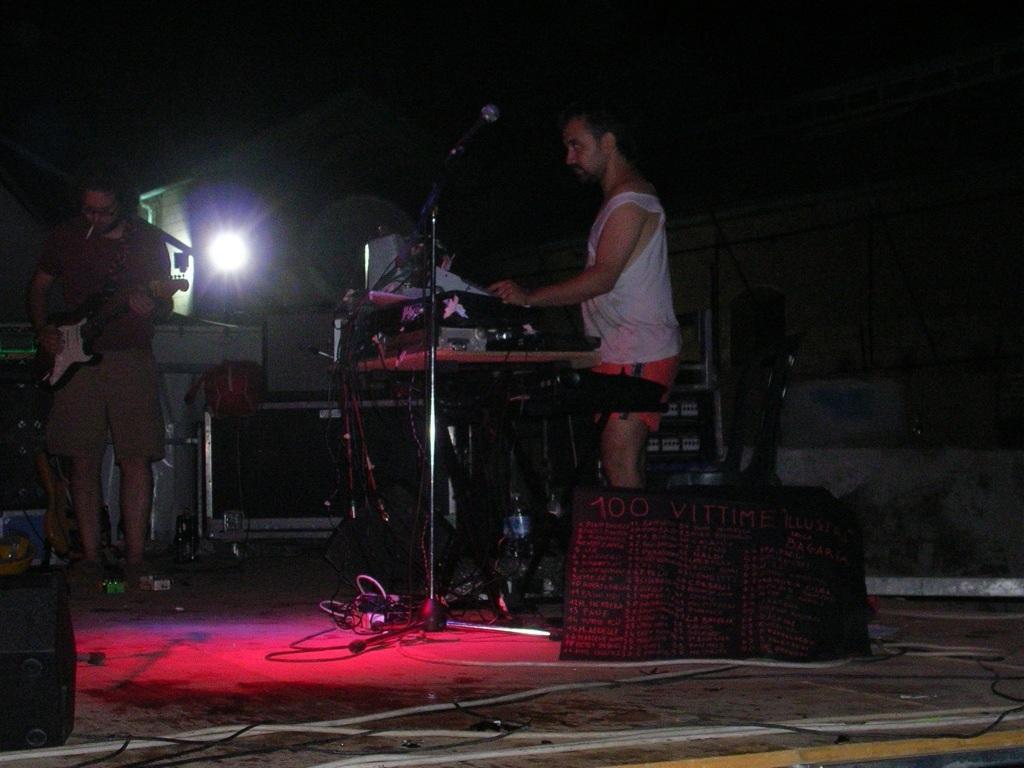Could you give a brief overview of what you see in this image? The picture is taken on the stage where the people are standing, at the right corner of the picture one person is standing and wearing shorts in front of the keyboard and another person is standing at the left corner of the picture playing guitar and wearing shorts and behind them there are lights and speakers and some wires on the stage. 